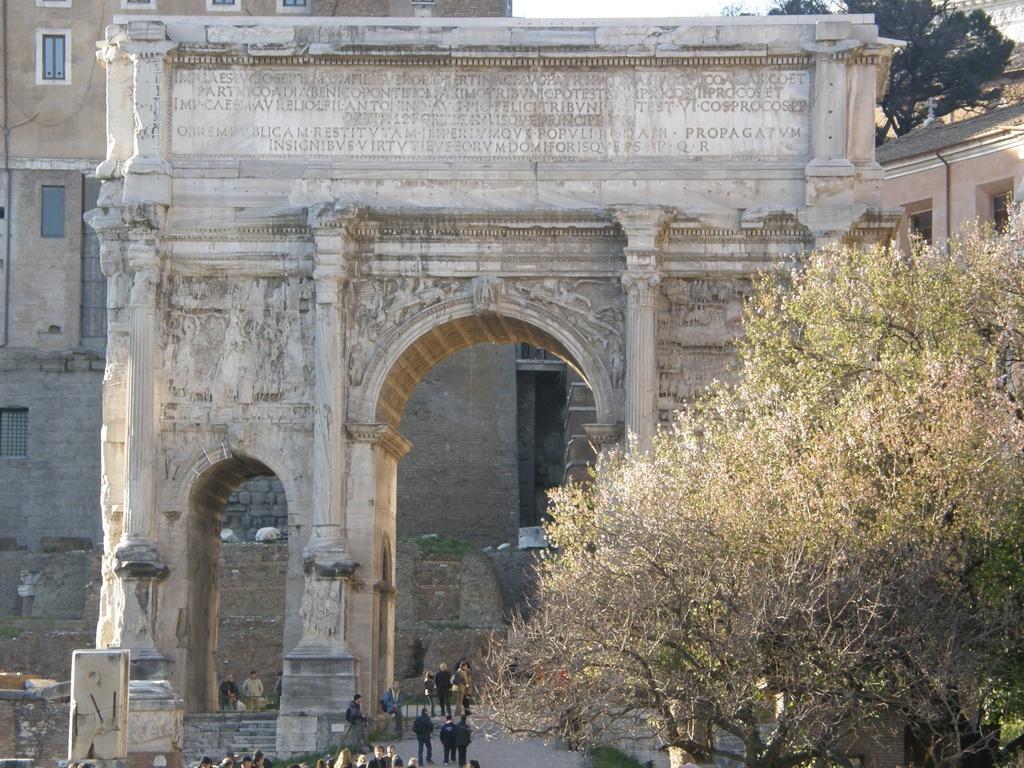In one or two sentences, can you explain what this image depicts? In this picture I can see the arc and monuments. In the background I can see the building and trees. At the bottom I can see many people were standing near to the stairs. At the top there is a sky. 